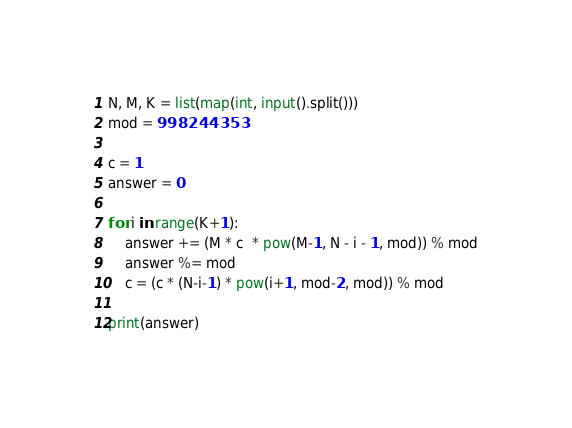<code> <loc_0><loc_0><loc_500><loc_500><_Python_>N, M, K = list(map(int, input().split()))
mod = 998244353

c = 1
answer = 0

for i in range(K+1):
    answer += (M * c  * pow(M-1, N - i - 1, mod)) % mod
    answer %= mod
    c = (c * (N-i-1) * pow(i+1, mod-2, mod)) % mod
    
print(answer)</code> 